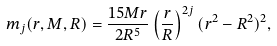<formula> <loc_0><loc_0><loc_500><loc_500>m _ { j } ( r , M , R ) = \frac { 1 5 M r } { 2 R ^ { 5 } } \left ( \frac { r } { R } \right ) ^ { 2 j } ( r ^ { 2 } - R ^ { 2 } ) ^ { 2 } ,</formula> 